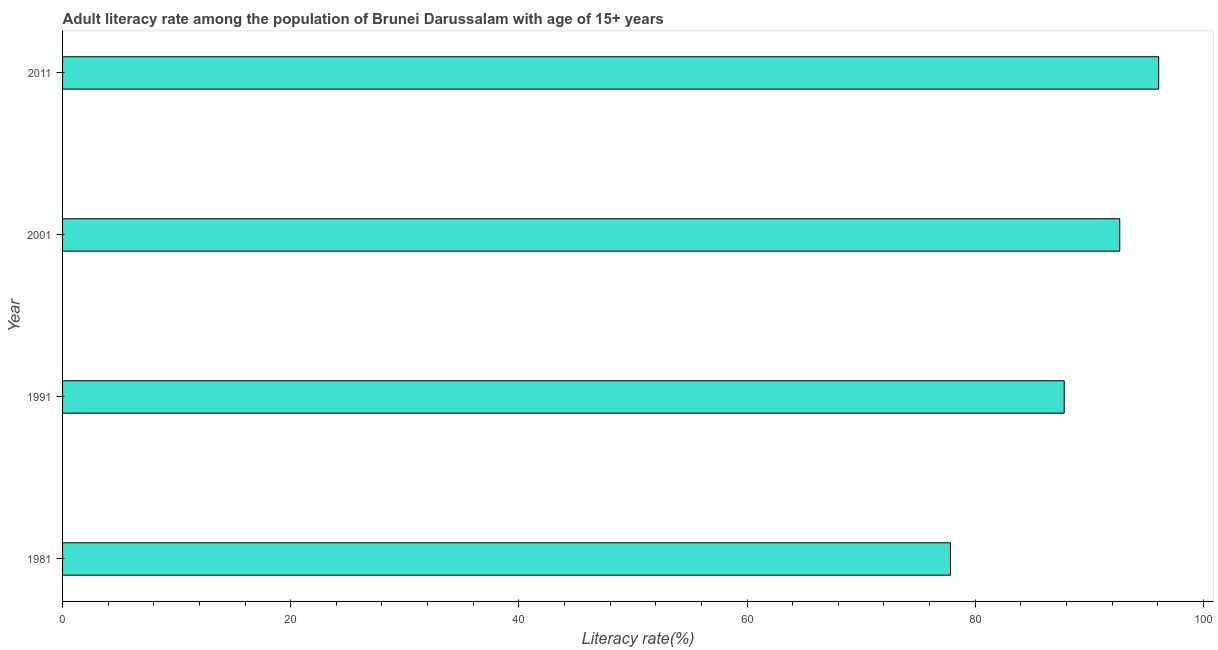Does the graph contain grids?
Your answer should be compact. No. What is the title of the graph?
Provide a short and direct response. Adult literacy rate among the population of Brunei Darussalam with age of 15+ years. What is the label or title of the X-axis?
Give a very brief answer. Literacy rate(%). What is the label or title of the Y-axis?
Offer a very short reply. Year. What is the adult literacy rate in 2001?
Offer a terse response. 92.67. Across all years, what is the maximum adult literacy rate?
Give a very brief answer. 96.09. Across all years, what is the minimum adult literacy rate?
Give a very brief answer. 77.83. In which year was the adult literacy rate maximum?
Your answer should be compact. 2011. What is the sum of the adult literacy rate?
Provide a succinct answer. 354.4. What is the difference between the adult literacy rate in 1981 and 2011?
Keep it short and to the point. -18.25. What is the average adult literacy rate per year?
Your response must be concise. 88.6. What is the median adult literacy rate?
Provide a succinct answer. 90.24. In how many years, is the adult literacy rate greater than 72 %?
Your response must be concise. 4. What is the ratio of the adult literacy rate in 1981 to that in 2011?
Your answer should be compact. 0.81. Is the adult literacy rate in 1991 less than that in 2001?
Provide a succinct answer. Yes. Is the difference between the adult literacy rate in 1981 and 2001 greater than the difference between any two years?
Offer a very short reply. No. What is the difference between the highest and the second highest adult literacy rate?
Make the answer very short. 3.41. Is the sum of the adult literacy rate in 1981 and 2011 greater than the maximum adult literacy rate across all years?
Your response must be concise. Yes. What is the difference between the highest and the lowest adult literacy rate?
Offer a terse response. 18.25. Are all the bars in the graph horizontal?
Your response must be concise. Yes. How many years are there in the graph?
Provide a succinct answer. 4. What is the difference between two consecutive major ticks on the X-axis?
Your answer should be very brief. 20. Are the values on the major ticks of X-axis written in scientific E-notation?
Give a very brief answer. No. What is the Literacy rate(%) of 1981?
Provide a short and direct response. 77.83. What is the Literacy rate(%) in 1991?
Make the answer very short. 87.8. What is the Literacy rate(%) of 2001?
Offer a very short reply. 92.67. What is the Literacy rate(%) in 2011?
Provide a succinct answer. 96.09. What is the difference between the Literacy rate(%) in 1981 and 1991?
Ensure brevity in your answer.  -9.97. What is the difference between the Literacy rate(%) in 1981 and 2001?
Your response must be concise. -14.84. What is the difference between the Literacy rate(%) in 1981 and 2011?
Provide a short and direct response. -18.25. What is the difference between the Literacy rate(%) in 1991 and 2001?
Offer a very short reply. -4.87. What is the difference between the Literacy rate(%) in 1991 and 2011?
Offer a terse response. -8.28. What is the difference between the Literacy rate(%) in 2001 and 2011?
Offer a very short reply. -3.41. What is the ratio of the Literacy rate(%) in 1981 to that in 1991?
Offer a very short reply. 0.89. What is the ratio of the Literacy rate(%) in 1981 to that in 2001?
Offer a very short reply. 0.84. What is the ratio of the Literacy rate(%) in 1981 to that in 2011?
Your answer should be compact. 0.81. What is the ratio of the Literacy rate(%) in 1991 to that in 2001?
Your answer should be compact. 0.95. What is the ratio of the Literacy rate(%) in 1991 to that in 2011?
Offer a terse response. 0.91. What is the ratio of the Literacy rate(%) in 2001 to that in 2011?
Provide a succinct answer. 0.96. 